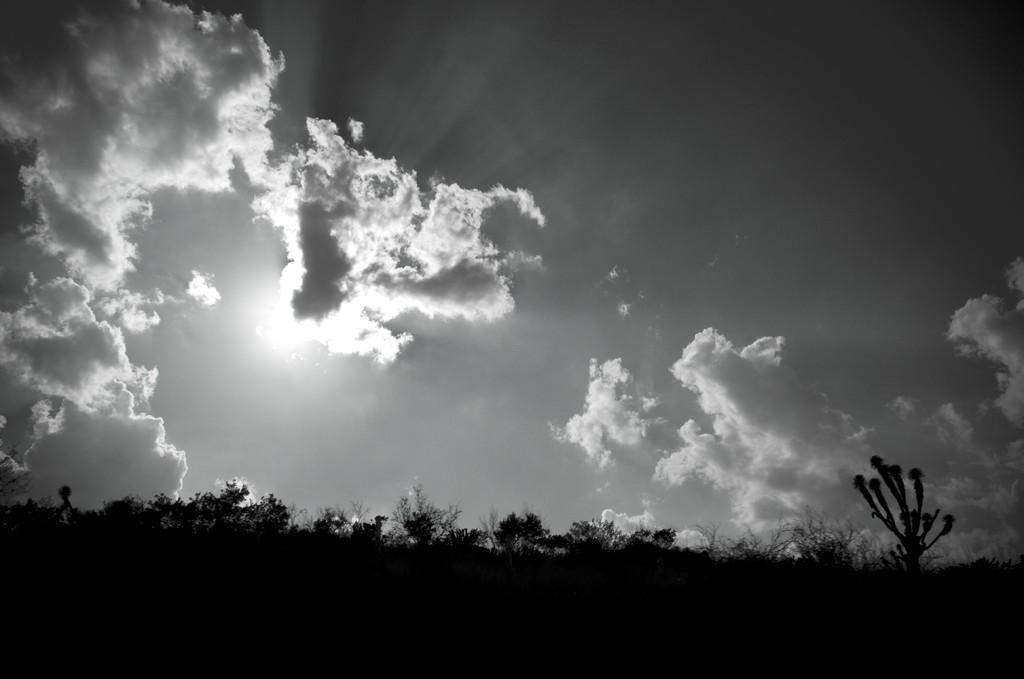What type of vegetation can be seen in the image? There are trees in the image. What is visible in the background of the image? The sky is visible in the background of the image. What can be seen in the sky in the image? There are clouds in the sky. Can you tell me how many planes are flying in the image? There are no planes visible in the image; it only features trees, sky, and clouds. 